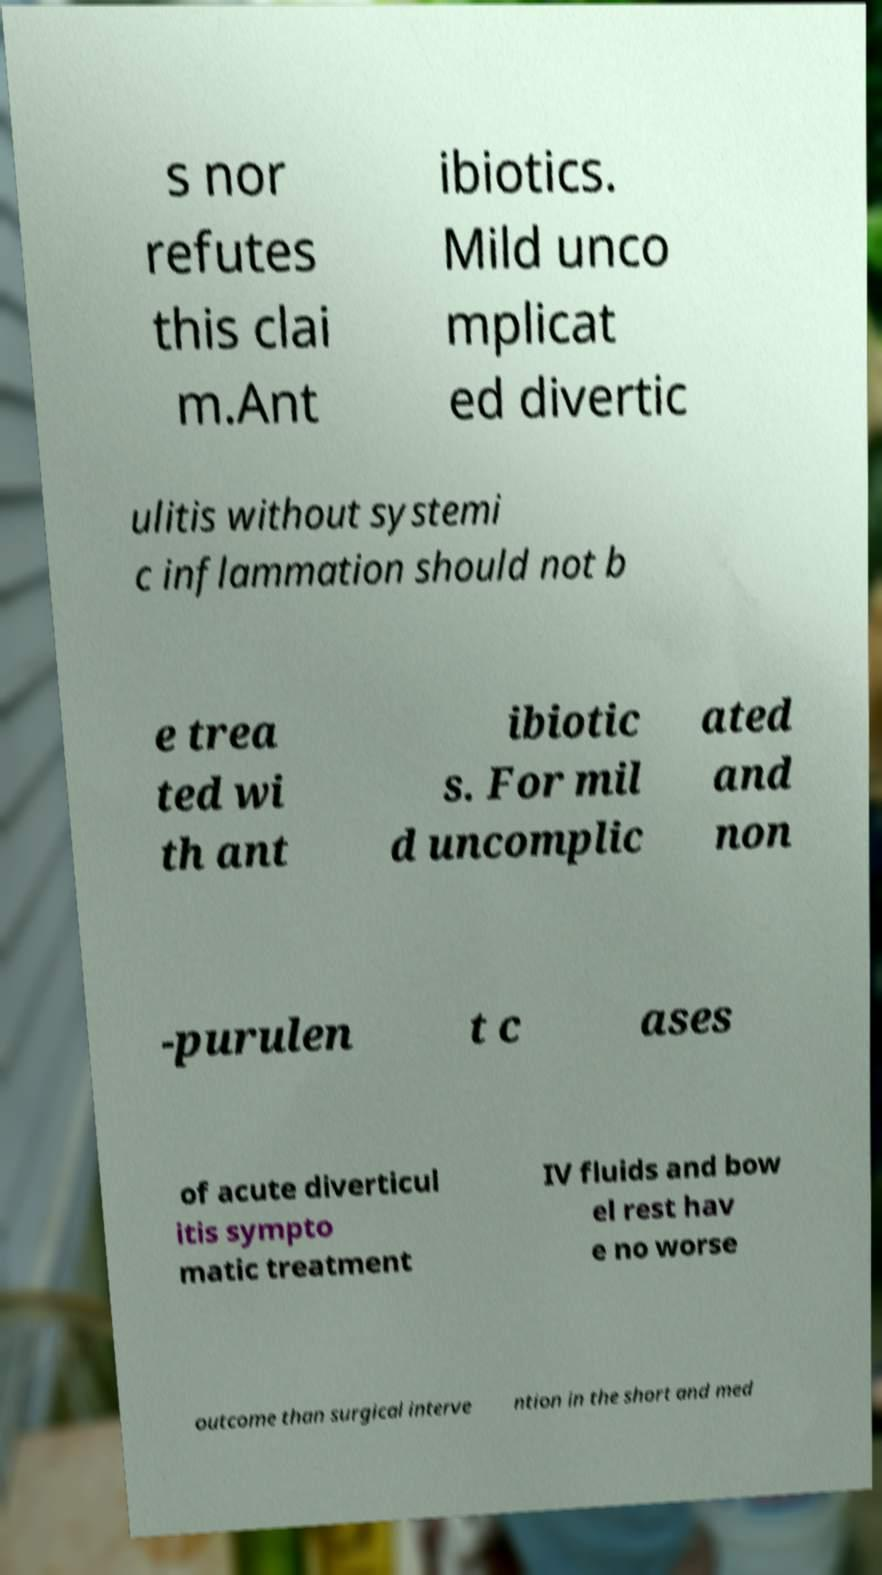Can you read and provide the text displayed in the image?This photo seems to have some interesting text. Can you extract and type it out for me? s nor refutes this clai m.Ant ibiotics. Mild unco mplicat ed divertic ulitis without systemi c inflammation should not b e trea ted wi th ant ibiotic s. For mil d uncomplic ated and non -purulen t c ases of acute diverticul itis sympto matic treatment IV fluids and bow el rest hav e no worse outcome than surgical interve ntion in the short and med 